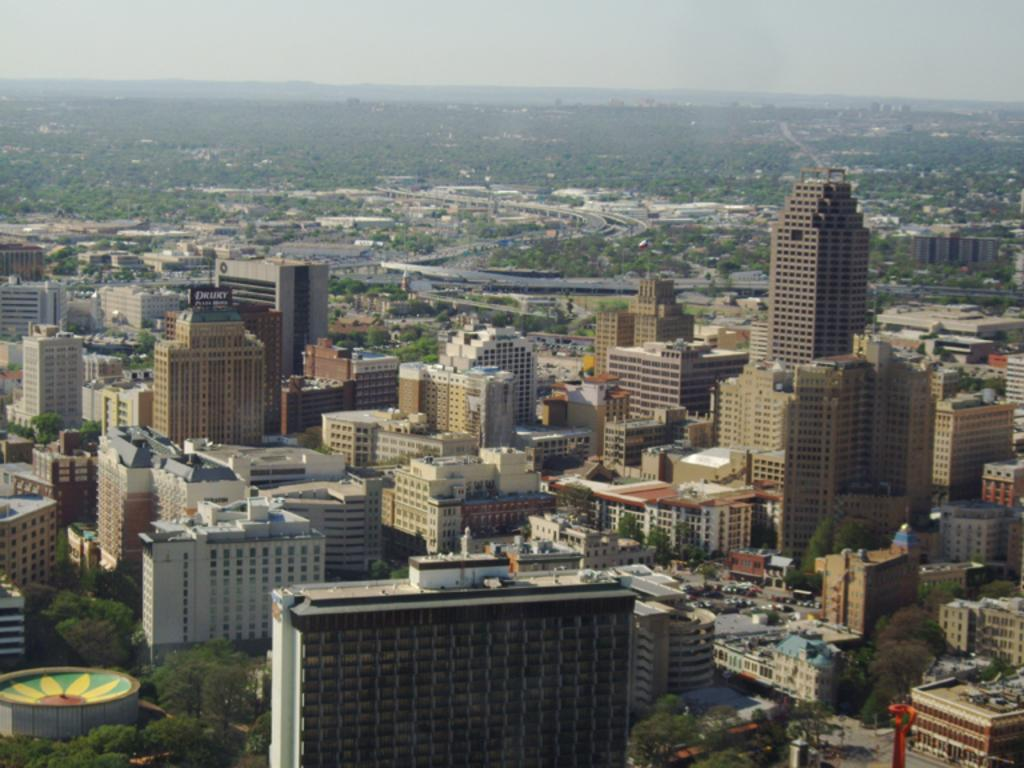What type of view is shown in the image? The image is an aerial view of a city. What can be seen in the image besides the sky? There are groups of buildings, trees, and a road visible in the image. How are the buildings arranged in the image? The groups of buildings are arranged in clusters or neighborhoods. What is visible at the top of the image? The sky is visible at the top of the image. Can you see a chain of ants marching across the road in the image? There are no ants present in the image, so it is not possible to see a chain of ants marching across the road. 